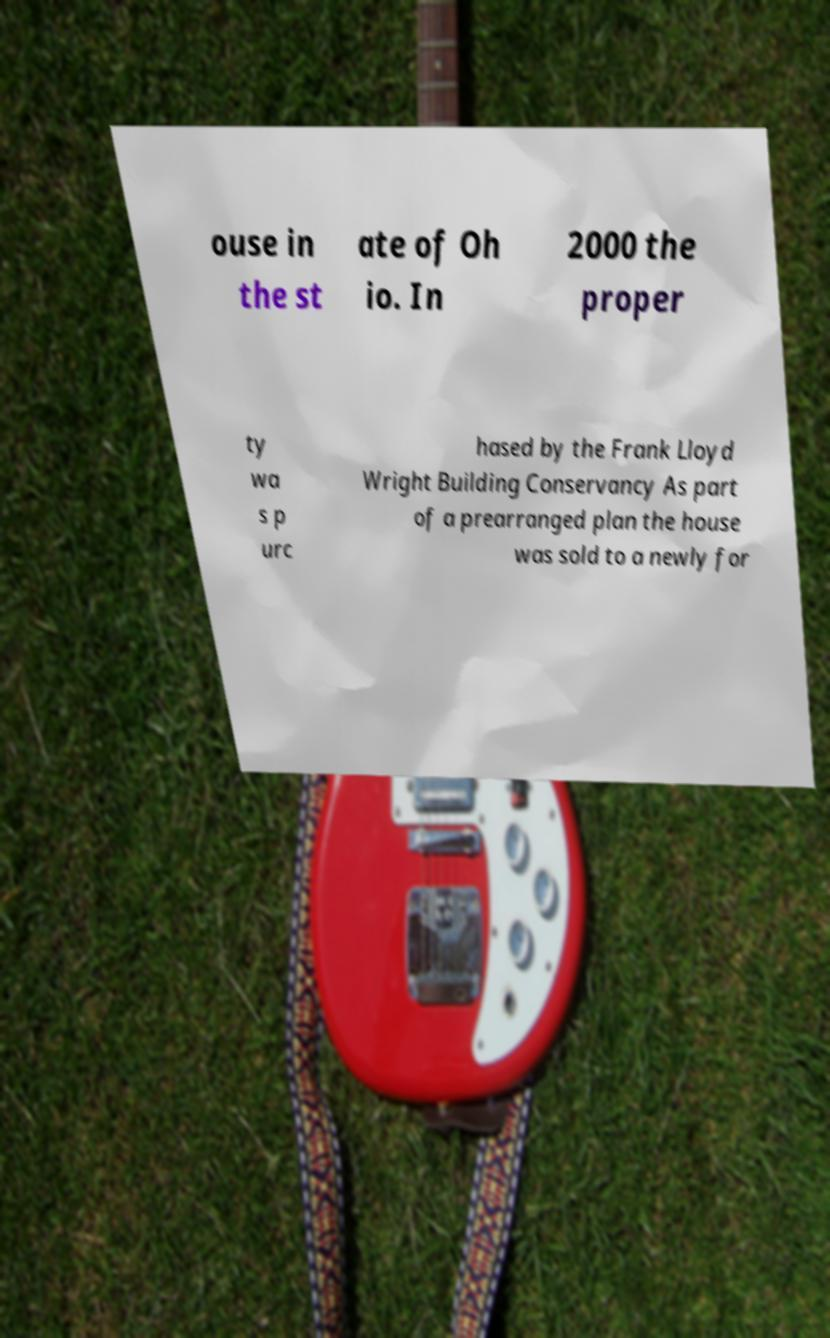Could you assist in decoding the text presented in this image and type it out clearly? ouse in the st ate of Oh io. In 2000 the proper ty wa s p urc hased by the Frank Lloyd Wright Building Conservancy As part of a prearranged plan the house was sold to a newly for 